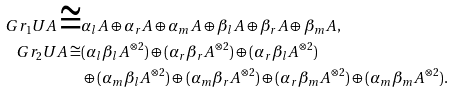Convert formula to latex. <formula><loc_0><loc_0><loc_500><loc_500>G r _ { 1 } U A \cong & \alpha _ { l } A \oplus \alpha _ { r } A \oplus \alpha _ { m } A \oplus \beta _ { l } A \oplus \beta _ { r } A \oplus \beta _ { m } A , \\ G r _ { 2 } U A \cong & ( \alpha _ { l } \beta _ { l } A ^ { \otimes 2 } ) \oplus ( \alpha _ { r } \beta _ { r } A ^ { \otimes 2 } ) \oplus ( \alpha _ { r } \beta _ { l } A ^ { \otimes 2 } ) \\ & \oplus ( \alpha _ { m } \beta _ { l } A ^ { \otimes 2 } ) \oplus ( \alpha _ { m } \beta _ { r } A ^ { \otimes 2 } ) \oplus ( \alpha _ { r } \beta _ { m } A ^ { \otimes 2 } ) \oplus ( \alpha _ { m } \beta _ { m } A ^ { \otimes 2 } ) .</formula> 